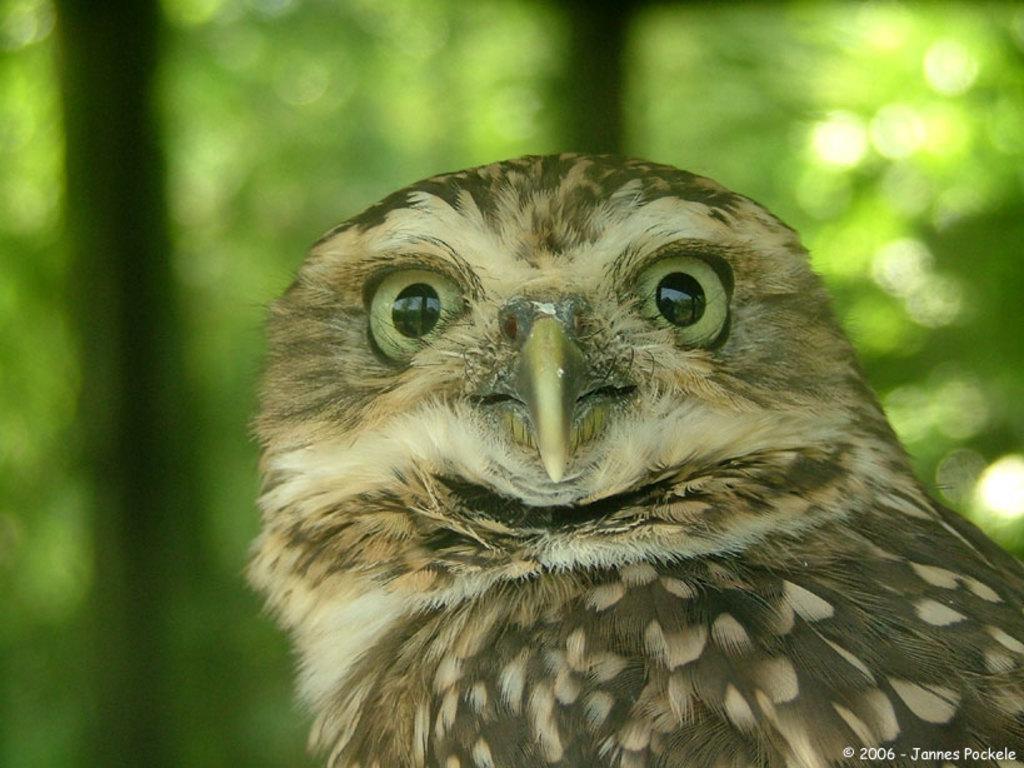How would you summarize this image in a sentence or two? In this picture I can see an owl, there is blur background and there is a watermark on the image. 